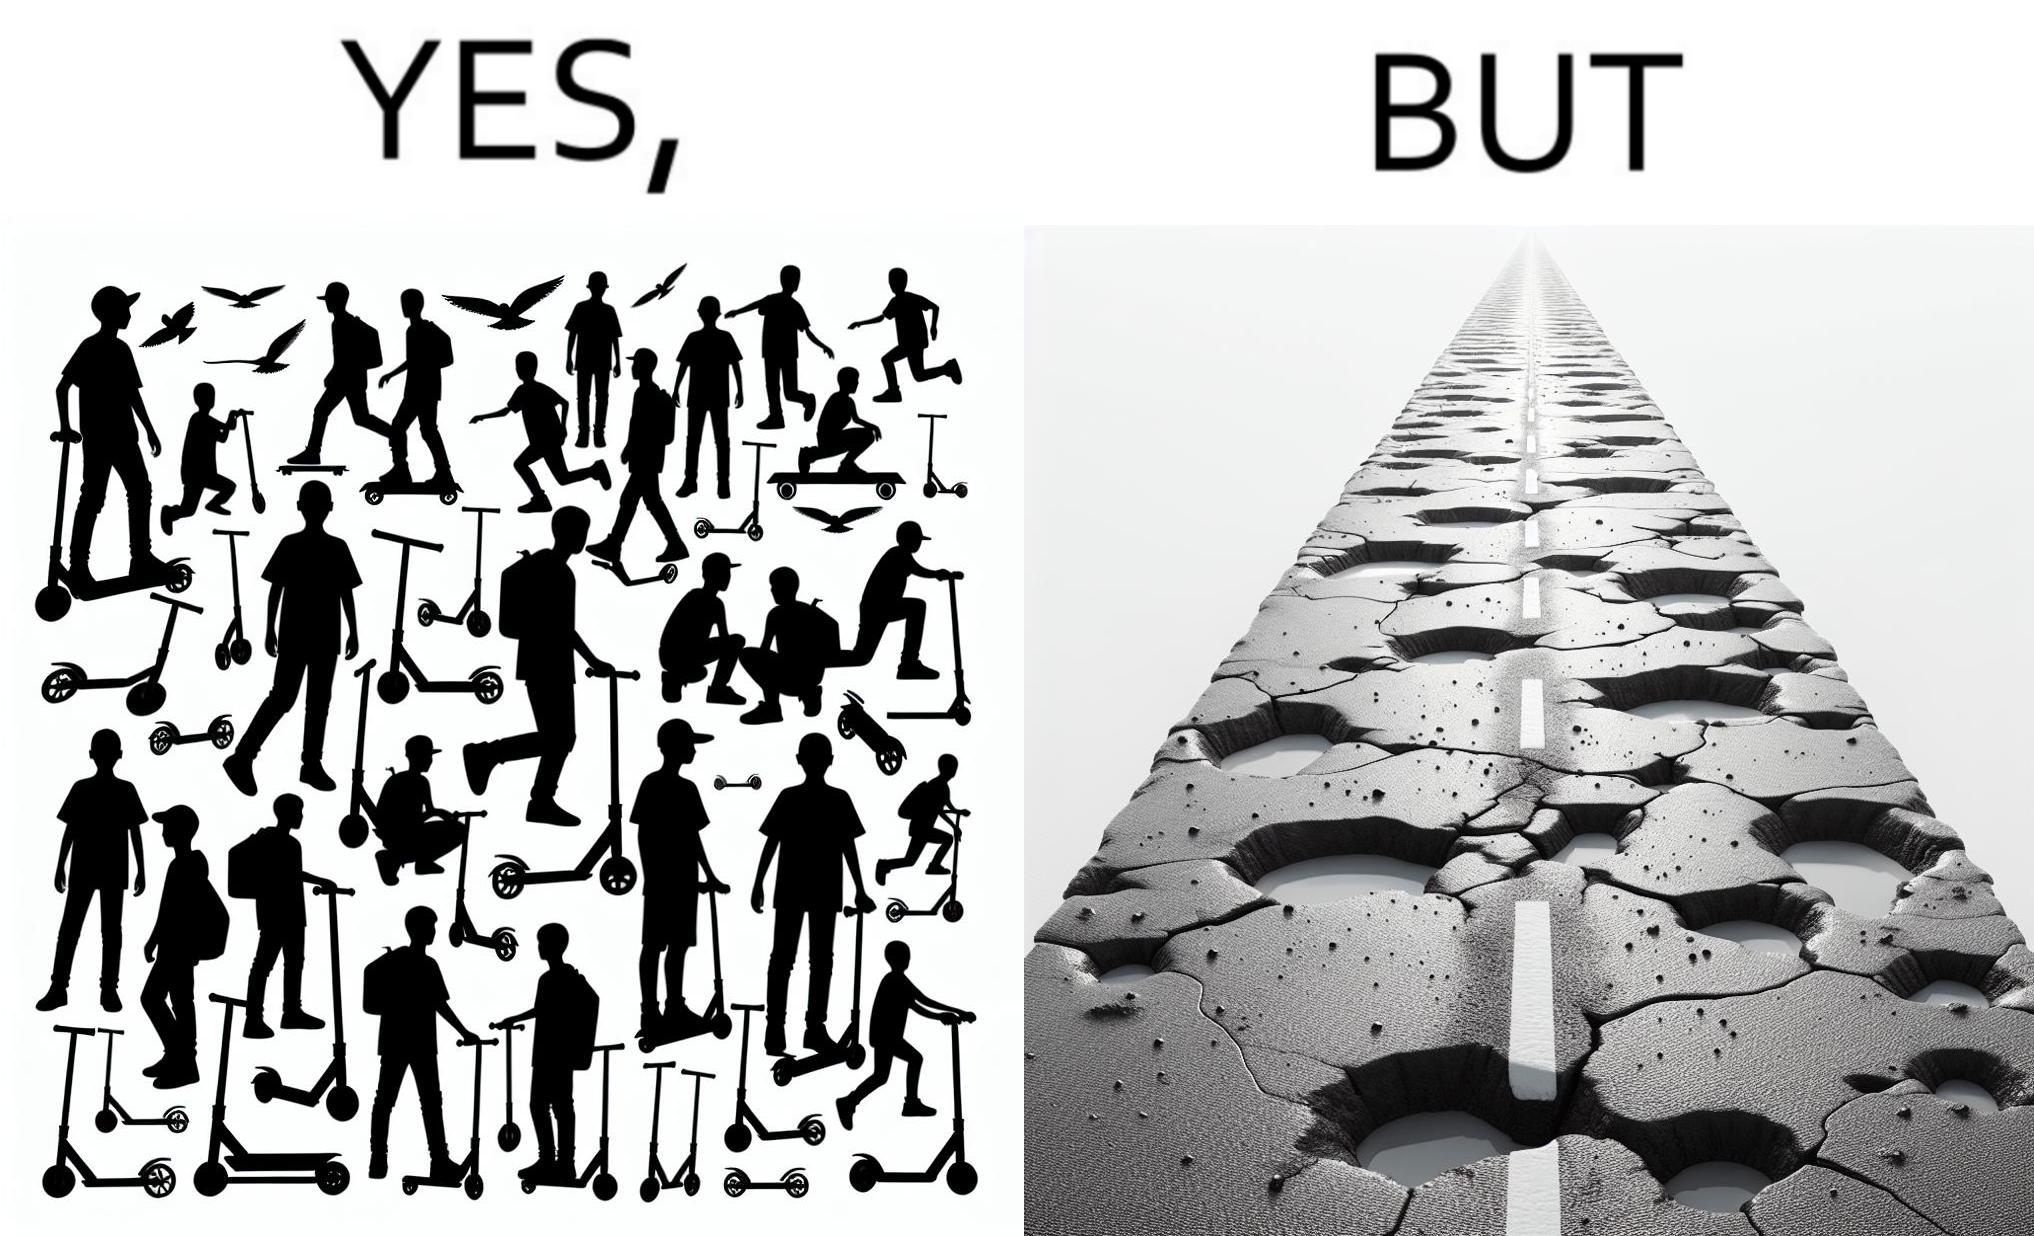Describe the contrast between the left and right parts of this image. In the left part of the image: many skateboard scooters parked together In the right part of the image: a straight road with many potholes 